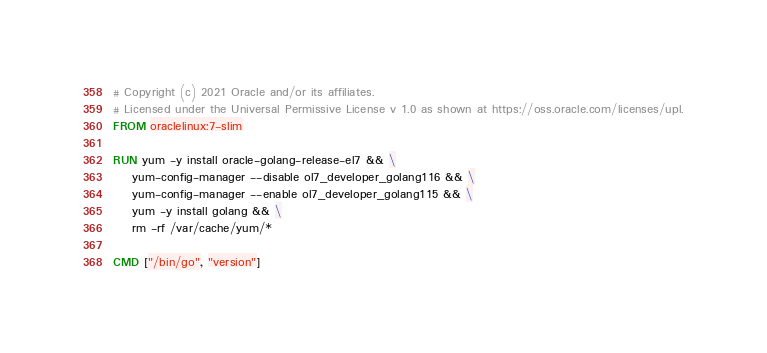Convert code to text. <code><loc_0><loc_0><loc_500><loc_500><_Dockerfile_># Copyright (c) 2021 Oracle and/or its affiliates.
# Licensed under the Universal Permissive License v 1.0 as shown at https://oss.oracle.com/licenses/upl.
FROM oraclelinux:7-slim

RUN yum -y install oracle-golang-release-el7 && \
    yum-config-manager --disable ol7_developer_golang116 && \
    yum-config-manager --enable ol7_developer_golang115 && \
    yum -y install golang && \
    rm -rf /var/cache/yum/*

CMD ["/bin/go", "version"]
</code> 